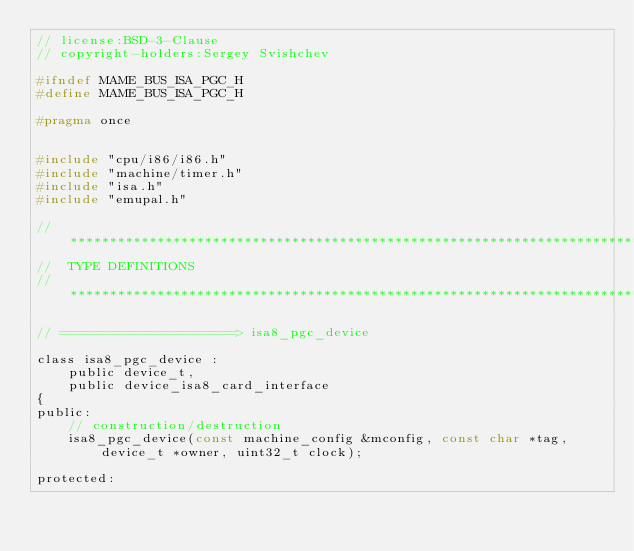<code> <loc_0><loc_0><loc_500><loc_500><_C_>// license:BSD-3-Clause
// copyright-holders:Sergey Svishchev

#ifndef MAME_BUS_ISA_PGC_H
#define MAME_BUS_ISA_PGC_H

#pragma once


#include "cpu/i86/i86.h"
#include "machine/timer.h"
#include "isa.h"
#include "emupal.h"

//**************************************************************************
//  TYPE DEFINITIONS
//**************************************************************************

// ======================> isa8_pgc_device

class isa8_pgc_device :
	public device_t,
	public device_isa8_card_interface
{
public:
	// construction/destruction
	isa8_pgc_device(const machine_config &mconfig, const char *tag, device_t *owner, uint32_t clock);

protected:</code> 